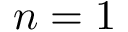Convert formula to latex. <formula><loc_0><loc_0><loc_500><loc_500>n = 1</formula> 